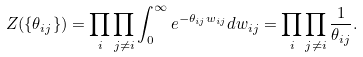Convert formula to latex. <formula><loc_0><loc_0><loc_500><loc_500>Z ( \{ \theta _ { i j } \} ) = \prod _ { i } \prod _ { j \neq i } \int _ { 0 } ^ { \infty } e ^ { - \theta _ { i j } w _ { i j } } d w _ { i j } = \prod _ { i } \prod _ { j \neq i } \frac { 1 } { \theta _ { i j } } .</formula> 